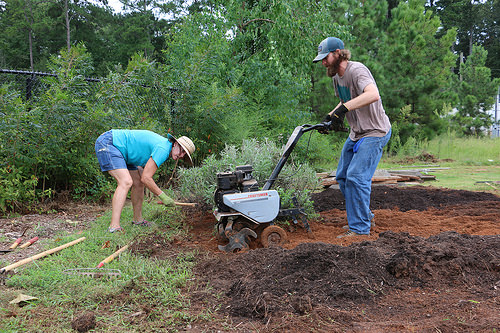<image>
Is the man in the ground? No. The man is not contained within the ground. These objects have a different spatial relationship. 